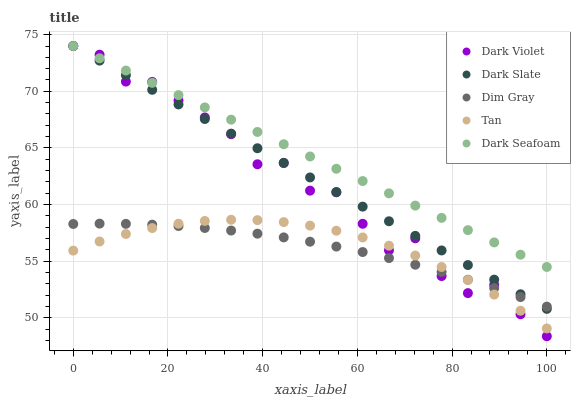Does Dim Gray have the minimum area under the curve?
Answer yes or no. Yes. Does Dark Seafoam have the maximum area under the curve?
Answer yes or no. Yes. Does Tan have the minimum area under the curve?
Answer yes or no. No. Does Tan have the maximum area under the curve?
Answer yes or no. No. Is Dark Seafoam the smoothest?
Answer yes or no. Yes. Is Dark Violet the roughest?
Answer yes or no. Yes. Is Tan the smoothest?
Answer yes or no. No. Is Tan the roughest?
Answer yes or no. No. Does Dark Violet have the lowest value?
Answer yes or no. Yes. Does Tan have the lowest value?
Answer yes or no. No. Does Dark Violet have the highest value?
Answer yes or no. Yes. Does Tan have the highest value?
Answer yes or no. No. Is Tan less than Dark Seafoam?
Answer yes or no. Yes. Is Dark Slate greater than Tan?
Answer yes or no. Yes. Does Dark Seafoam intersect Dark Violet?
Answer yes or no. Yes. Is Dark Seafoam less than Dark Violet?
Answer yes or no. No. Is Dark Seafoam greater than Dark Violet?
Answer yes or no. No. Does Tan intersect Dark Seafoam?
Answer yes or no. No. 